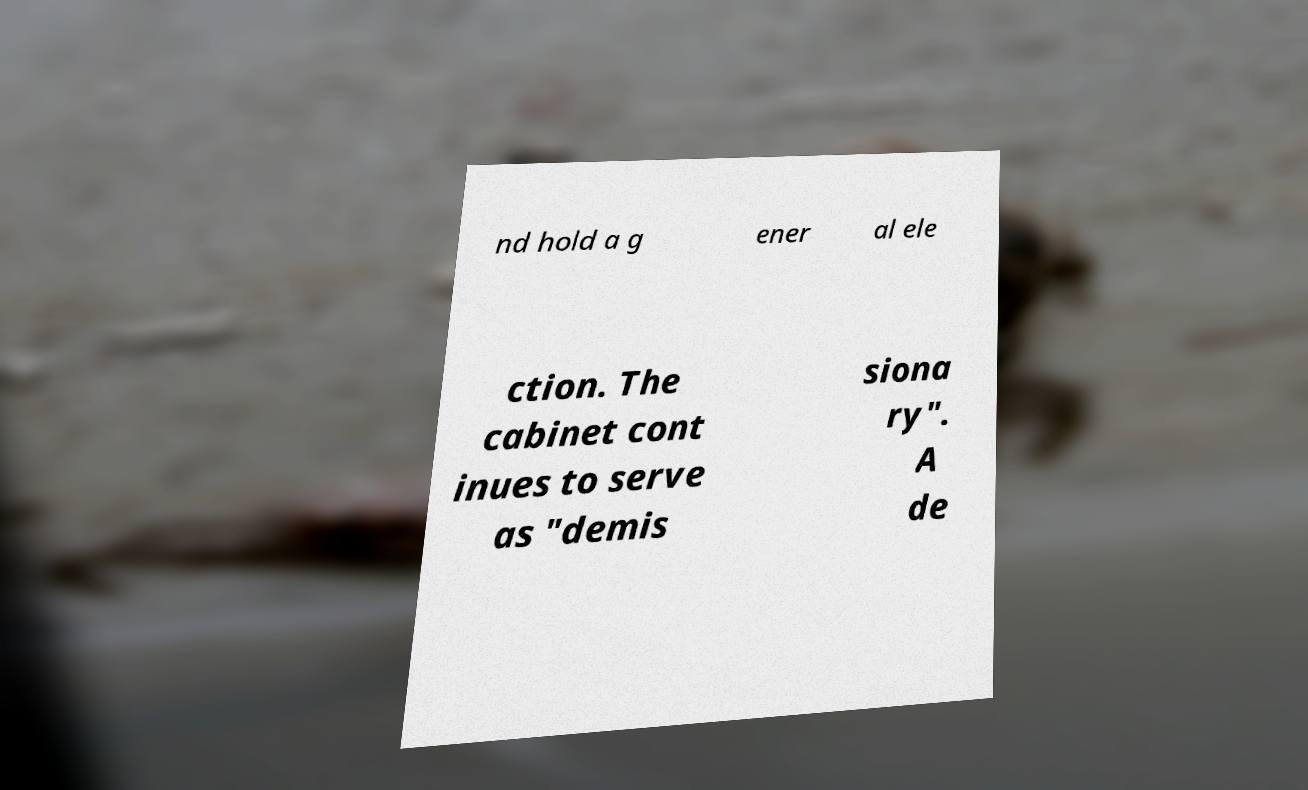Can you read and provide the text displayed in the image?This photo seems to have some interesting text. Can you extract and type it out for me? nd hold a g ener al ele ction. The cabinet cont inues to serve as "demis siona ry". A de 